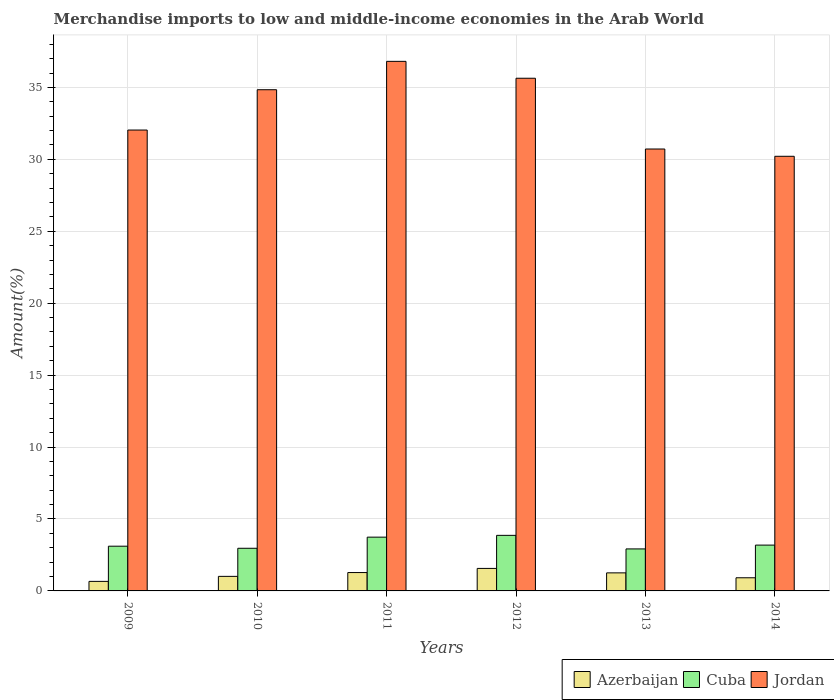How many different coloured bars are there?
Provide a succinct answer. 3. Are the number of bars per tick equal to the number of legend labels?
Your answer should be very brief. Yes. Are the number of bars on each tick of the X-axis equal?
Your response must be concise. Yes. How many bars are there on the 3rd tick from the left?
Provide a short and direct response. 3. In how many cases, is the number of bars for a given year not equal to the number of legend labels?
Make the answer very short. 0. What is the percentage of amount earned from merchandise imports in Jordan in 2011?
Make the answer very short. 36.81. Across all years, what is the maximum percentage of amount earned from merchandise imports in Jordan?
Ensure brevity in your answer.  36.81. Across all years, what is the minimum percentage of amount earned from merchandise imports in Azerbaijan?
Your answer should be compact. 0.66. In which year was the percentage of amount earned from merchandise imports in Azerbaijan minimum?
Make the answer very short. 2009. What is the total percentage of amount earned from merchandise imports in Cuba in the graph?
Your answer should be very brief. 19.78. What is the difference between the percentage of amount earned from merchandise imports in Jordan in 2010 and that in 2014?
Provide a succinct answer. 4.63. What is the difference between the percentage of amount earned from merchandise imports in Jordan in 2010 and the percentage of amount earned from merchandise imports in Azerbaijan in 2014?
Give a very brief answer. 33.93. What is the average percentage of amount earned from merchandise imports in Cuba per year?
Keep it short and to the point. 3.3. In the year 2014, what is the difference between the percentage of amount earned from merchandise imports in Jordan and percentage of amount earned from merchandise imports in Azerbaijan?
Offer a terse response. 29.3. In how many years, is the percentage of amount earned from merchandise imports in Azerbaijan greater than 5 %?
Offer a terse response. 0. What is the ratio of the percentage of amount earned from merchandise imports in Cuba in 2012 to that in 2014?
Give a very brief answer. 1.21. Is the difference between the percentage of amount earned from merchandise imports in Jordan in 2012 and 2013 greater than the difference between the percentage of amount earned from merchandise imports in Azerbaijan in 2012 and 2013?
Offer a terse response. Yes. What is the difference between the highest and the second highest percentage of amount earned from merchandise imports in Azerbaijan?
Make the answer very short. 0.29. What is the difference between the highest and the lowest percentage of amount earned from merchandise imports in Jordan?
Ensure brevity in your answer.  6.6. In how many years, is the percentage of amount earned from merchandise imports in Jordan greater than the average percentage of amount earned from merchandise imports in Jordan taken over all years?
Your answer should be very brief. 3. What does the 2nd bar from the left in 2010 represents?
Your response must be concise. Cuba. What does the 2nd bar from the right in 2012 represents?
Your response must be concise. Cuba. How many bars are there?
Ensure brevity in your answer.  18. How many years are there in the graph?
Offer a very short reply. 6. Are the values on the major ticks of Y-axis written in scientific E-notation?
Offer a terse response. No. Does the graph contain grids?
Ensure brevity in your answer.  Yes. Where does the legend appear in the graph?
Keep it short and to the point. Bottom right. How many legend labels are there?
Ensure brevity in your answer.  3. How are the legend labels stacked?
Your response must be concise. Horizontal. What is the title of the graph?
Your answer should be very brief. Merchandise imports to low and middle-income economies in the Arab World. What is the label or title of the X-axis?
Offer a very short reply. Years. What is the label or title of the Y-axis?
Your response must be concise. Amount(%). What is the Amount(%) of Azerbaijan in 2009?
Keep it short and to the point. 0.66. What is the Amount(%) in Cuba in 2009?
Offer a very short reply. 3.11. What is the Amount(%) in Jordan in 2009?
Keep it short and to the point. 32.04. What is the Amount(%) of Azerbaijan in 2010?
Your answer should be compact. 1.01. What is the Amount(%) in Cuba in 2010?
Make the answer very short. 2.96. What is the Amount(%) of Jordan in 2010?
Your answer should be very brief. 34.84. What is the Amount(%) in Azerbaijan in 2011?
Ensure brevity in your answer.  1.28. What is the Amount(%) in Cuba in 2011?
Keep it short and to the point. 3.74. What is the Amount(%) in Jordan in 2011?
Provide a succinct answer. 36.81. What is the Amount(%) in Azerbaijan in 2012?
Make the answer very short. 1.57. What is the Amount(%) of Cuba in 2012?
Make the answer very short. 3.86. What is the Amount(%) in Jordan in 2012?
Your response must be concise. 35.64. What is the Amount(%) of Azerbaijan in 2013?
Keep it short and to the point. 1.25. What is the Amount(%) of Cuba in 2013?
Provide a short and direct response. 2.92. What is the Amount(%) in Jordan in 2013?
Give a very brief answer. 30.72. What is the Amount(%) of Azerbaijan in 2014?
Ensure brevity in your answer.  0.91. What is the Amount(%) in Cuba in 2014?
Offer a terse response. 3.19. What is the Amount(%) of Jordan in 2014?
Provide a short and direct response. 30.21. Across all years, what is the maximum Amount(%) in Azerbaijan?
Provide a succinct answer. 1.57. Across all years, what is the maximum Amount(%) of Cuba?
Keep it short and to the point. 3.86. Across all years, what is the maximum Amount(%) of Jordan?
Offer a very short reply. 36.81. Across all years, what is the minimum Amount(%) in Azerbaijan?
Make the answer very short. 0.66. Across all years, what is the minimum Amount(%) in Cuba?
Your answer should be very brief. 2.92. Across all years, what is the minimum Amount(%) of Jordan?
Make the answer very short. 30.21. What is the total Amount(%) in Azerbaijan in the graph?
Make the answer very short. 6.68. What is the total Amount(%) in Cuba in the graph?
Provide a short and direct response. 19.78. What is the total Amount(%) of Jordan in the graph?
Provide a short and direct response. 200.26. What is the difference between the Amount(%) in Azerbaijan in 2009 and that in 2010?
Offer a terse response. -0.35. What is the difference between the Amount(%) in Cuba in 2009 and that in 2010?
Make the answer very short. 0.14. What is the difference between the Amount(%) of Jordan in 2009 and that in 2010?
Give a very brief answer. -2.8. What is the difference between the Amount(%) of Azerbaijan in 2009 and that in 2011?
Your answer should be compact. -0.61. What is the difference between the Amount(%) in Cuba in 2009 and that in 2011?
Offer a terse response. -0.63. What is the difference between the Amount(%) of Jordan in 2009 and that in 2011?
Make the answer very short. -4.77. What is the difference between the Amount(%) of Azerbaijan in 2009 and that in 2012?
Your answer should be compact. -0.9. What is the difference between the Amount(%) of Cuba in 2009 and that in 2012?
Your response must be concise. -0.75. What is the difference between the Amount(%) of Jordan in 2009 and that in 2012?
Provide a succinct answer. -3.6. What is the difference between the Amount(%) in Azerbaijan in 2009 and that in 2013?
Your answer should be compact. -0.59. What is the difference between the Amount(%) in Cuba in 2009 and that in 2013?
Provide a short and direct response. 0.19. What is the difference between the Amount(%) of Jordan in 2009 and that in 2013?
Offer a terse response. 1.32. What is the difference between the Amount(%) in Azerbaijan in 2009 and that in 2014?
Keep it short and to the point. -0.25. What is the difference between the Amount(%) in Cuba in 2009 and that in 2014?
Your response must be concise. -0.08. What is the difference between the Amount(%) in Jordan in 2009 and that in 2014?
Make the answer very short. 1.82. What is the difference between the Amount(%) in Azerbaijan in 2010 and that in 2011?
Ensure brevity in your answer.  -0.26. What is the difference between the Amount(%) of Cuba in 2010 and that in 2011?
Ensure brevity in your answer.  -0.77. What is the difference between the Amount(%) in Jordan in 2010 and that in 2011?
Keep it short and to the point. -1.97. What is the difference between the Amount(%) of Azerbaijan in 2010 and that in 2012?
Your answer should be compact. -0.55. What is the difference between the Amount(%) in Cuba in 2010 and that in 2012?
Offer a terse response. -0.9. What is the difference between the Amount(%) of Jordan in 2010 and that in 2012?
Your answer should be very brief. -0.8. What is the difference between the Amount(%) of Azerbaijan in 2010 and that in 2013?
Provide a short and direct response. -0.24. What is the difference between the Amount(%) of Cuba in 2010 and that in 2013?
Ensure brevity in your answer.  0.05. What is the difference between the Amount(%) of Jordan in 2010 and that in 2013?
Give a very brief answer. 4.12. What is the difference between the Amount(%) of Azerbaijan in 2010 and that in 2014?
Your answer should be compact. 0.1. What is the difference between the Amount(%) of Cuba in 2010 and that in 2014?
Give a very brief answer. -0.22. What is the difference between the Amount(%) in Jordan in 2010 and that in 2014?
Provide a succinct answer. 4.63. What is the difference between the Amount(%) in Azerbaijan in 2011 and that in 2012?
Keep it short and to the point. -0.29. What is the difference between the Amount(%) in Cuba in 2011 and that in 2012?
Your answer should be compact. -0.12. What is the difference between the Amount(%) of Jordan in 2011 and that in 2012?
Your answer should be compact. 1.17. What is the difference between the Amount(%) in Azerbaijan in 2011 and that in 2013?
Ensure brevity in your answer.  0.02. What is the difference between the Amount(%) of Cuba in 2011 and that in 2013?
Give a very brief answer. 0.82. What is the difference between the Amount(%) in Jordan in 2011 and that in 2013?
Offer a very short reply. 6.09. What is the difference between the Amount(%) of Azerbaijan in 2011 and that in 2014?
Offer a terse response. 0.36. What is the difference between the Amount(%) of Cuba in 2011 and that in 2014?
Ensure brevity in your answer.  0.55. What is the difference between the Amount(%) in Jordan in 2011 and that in 2014?
Give a very brief answer. 6.6. What is the difference between the Amount(%) in Azerbaijan in 2012 and that in 2013?
Offer a terse response. 0.31. What is the difference between the Amount(%) in Cuba in 2012 and that in 2013?
Make the answer very short. 0.94. What is the difference between the Amount(%) of Jordan in 2012 and that in 2013?
Ensure brevity in your answer.  4.92. What is the difference between the Amount(%) in Azerbaijan in 2012 and that in 2014?
Ensure brevity in your answer.  0.65. What is the difference between the Amount(%) in Cuba in 2012 and that in 2014?
Keep it short and to the point. 0.68. What is the difference between the Amount(%) in Jordan in 2012 and that in 2014?
Provide a succinct answer. 5.43. What is the difference between the Amount(%) in Azerbaijan in 2013 and that in 2014?
Provide a short and direct response. 0.34. What is the difference between the Amount(%) of Cuba in 2013 and that in 2014?
Your answer should be compact. -0.27. What is the difference between the Amount(%) in Jordan in 2013 and that in 2014?
Keep it short and to the point. 0.51. What is the difference between the Amount(%) of Azerbaijan in 2009 and the Amount(%) of Cuba in 2010?
Offer a very short reply. -2.3. What is the difference between the Amount(%) of Azerbaijan in 2009 and the Amount(%) of Jordan in 2010?
Give a very brief answer. -34.18. What is the difference between the Amount(%) of Cuba in 2009 and the Amount(%) of Jordan in 2010?
Ensure brevity in your answer.  -31.73. What is the difference between the Amount(%) of Azerbaijan in 2009 and the Amount(%) of Cuba in 2011?
Your answer should be compact. -3.08. What is the difference between the Amount(%) of Azerbaijan in 2009 and the Amount(%) of Jordan in 2011?
Your answer should be very brief. -36.15. What is the difference between the Amount(%) in Cuba in 2009 and the Amount(%) in Jordan in 2011?
Offer a very short reply. -33.7. What is the difference between the Amount(%) of Azerbaijan in 2009 and the Amount(%) of Cuba in 2012?
Offer a terse response. -3.2. What is the difference between the Amount(%) of Azerbaijan in 2009 and the Amount(%) of Jordan in 2012?
Ensure brevity in your answer.  -34.98. What is the difference between the Amount(%) in Cuba in 2009 and the Amount(%) in Jordan in 2012?
Make the answer very short. -32.53. What is the difference between the Amount(%) in Azerbaijan in 2009 and the Amount(%) in Cuba in 2013?
Ensure brevity in your answer.  -2.26. What is the difference between the Amount(%) of Azerbaijan in 2009 and the Amount(%) of Jordan in 2013?
Give a very brief answer. -30.06. What is the difference between the Amount(%) in Cuba in 2009 and the Amount(%) in Jordan in 2013?
Your response must be concise. -27.61. What is the difference between the Amount(%) in Azerbaijan in 2009 and the Amount(%) in Cuba in 2014?
Provide a succinct answer. -2.52. What is the difference between the Amount(%) of Azerbaijan in 2009 and the Amount(%) of Jordan in 2014?
Your response must be concise. -29.55. What is the difference between the Amount(%) of Cuba in 2009 and the Amount(%) of Jordan in 2014?
Offer a very short reply. -27.1. What is the difference between the Amount(%) of Azerbaijan in 2010 and the Amount(%) of Cuba in 2011?
Your answer should be very brief. -2.73. What is the difference between the Amount(%) in Azerbaijan in 2010 and the Amount(%) in Jordan in 2011?
Give a very brief answer. -35.8. What is the difference between the Amount(%) in Cuba in 2010 and the Amount(%) in Jordan in 2011?
Give a very brief answer. -33.85. What is the difference between the Amount(%) in Azerbaijan in 2010 and the Amount(%) in Cuba in 2012?
Your response must be concise. -2.85. What is the difference between the Amount(%) in Azerbaijan in 2010 and the Amount(%) in Jordan in 2012?
Make the answer very short. -34.63. What is the difference between the Amount(%) of Cuba in 2010 and the Amount(%) of Jordan in 2012?
Offer a terse response. -32.67. What is the difference between the Amount(%) of Azerbaijan in 2010 and the Amount(%) of Cuba in 2013?
Provide a succinct answer. -1.91. What is the difference between the Amount(%) in Azerbaijan in 2010 and the Amount(%) in Jordan in 2013?
Provide a succinct answer. -29.71. What is the difference between the Amount(%) in Cuba in 2010 and the Amount(%) in Jordan in 2013?
Provide a short and direct response. -27.76. What is the difference between the Amount(%) in Azerbaijan in 2010 and the Amount(%) in Cuba in 2014?
Keep it short and to the point. -2.17. What is the difference between the Amount(%) in Azerbaijan in 2010 and the Amount(%) in Jordan in 2014?
Offer a terse response. -29.2. What is the difference between the Amount(%) in Cuba in 2010 and the Amount(%) in Jordan in 2014?
Provide a succinct answer. -27.25. What is the difference between the Amount(%) of Azerbaijan in 2011 and the Amount(%) of Cuba in 2012?
Your answer should be very brief. -2.59. What is the difference between the Amount(%) in Azerbaijan in 2011 and the Amount(%) in Jordan in 2012?
Give a very brief answer. -34.36. What is the difference between the Amount(%) of Cuba in 2011 and the Amount(%) of Jordan in 2012?
Give a very brief answer. -31.9. What is the difference between the Amount(%) of Azerbaijan in 2011 and the Amount(%) of Cuba in 2013?
Offer a very short reply. -1.64. What is the difference between the Amount(%) in Azerbaijan in 2011 and the Amount(%) in Jordan in 2013?
Your answer should be very brief. -29.44. What is the difference between the Amount(%) of Cuba in 2011 and the Amount(%) of Jordan in 2013?
Provide a succinct answer. -26.98. What is the difference between the Amount(%) of Azerbaijan in 2011 and the Amount(%) of Cuba in 2014?
Offer a very short reply. -1.91. What is the difference between the Amount(%) in Azerbaijan in 2011 and the Amount(%) in Jordan in 2014?
Keep it short and to the point. -28.94. What is the difference between the Amount(%) in Cuba in 2011 and the Amount(%) in Jordan in 2014?
Your answer should be very brief. -26.47. What is the difference between the Amount(%) of Azerbaijan in 2012 and the Amount(%) of Cuba in 2013?
Provide a short and direct response. -1.35. What is the difference between the Amount(%) in Azerbaijan in 2012 and the Amount(%) in Jordan in 2013?
Ensure brevity in your answer.  -29.16. What is the difference between the Amount(%) in Cuba in 2012 and the Amount(%) in Jordan in 2013?
Provide a short and direct response. -26.86. What is the difference between the Amount(%) in Azerbaijan in 2012 and the Amount(%) in Cuba in 2014?
Provide a short and direct response. -1.62. What is the difference between the Amount(%) of Azerbaijan in 2012 and the Amount(%) of Jordan in 2014?
Your answer should be very brief. -28.65. What is the difference between the Amount(%) in Cuba in 2012 and the Amount(%) in Jordan in 2014?
Keep it short and to the point. -26.35. What is the difference between the Amount(%) in Azerbaijan in 2013 and the Amount(%) in Cuba in 2014?
Your answer should be very brief. -1.93. What is the difference between the Amount(%) of Azerbaijan in 2013 and the Amount(%) of Jordan in 2014?
Ensure brevity in your answer.  -28.96. What is the difference between the Amount(%) of Cuba in 2013 and the Amount(%) of Jordan in 2014?
Provide a short and direct response. -27.29. What is the average Amount(%) of Azerbaijan per year?
Keep it short and to the point. 1.11. What is the average Amount(%) of Cuba per year?
Offer a very short reply. 3.3. What is the average Amount(%) in Jordan per year?
Make the answer very short. 33.38. In the year 2009, what is the difference between the Amount(%) of Azerbaijan and Amount(%) of Cuba?
Offer a terse response. -2.45. In the year 2009, what is the difference between the Amount(%) in Azerbaijan and Amount(%) in Jordan?
Your answer should be compact. -31.38. In the year 2009, what is the difference between the Amount(%) in Cuba and Amount(%) in Jordan?
Provide a short and direct response. -28.93. In the year 2010, what is the difference between the Amount(%) of Azerbaijan and Amount(%) of Cuba?
Offer a very short reply. -1.95. In the year 2010, what is the difference between the Amount(%) in Azerbaijan and Amount(%) in Jordan?
Provide a short and direct response. -33.83. In the year 2010, what is the difference between the Amount(%) in Cuba and Amount(%) in Jordan?
Give a very brief answer. -31.88. In the year 2011, what is the difference between the Amount(%) of Azerbaijan and Amount(%) of Cuba?
Offer a terse response. -2.46. In the year 2011, what is the difference between the Amount(%) of Azerbaijan and Amount(%) of Jordan?
Make the answer very short. -35.54. In the year 2011, what is the difference between the Amount(%) of Cuba and Amount(%) of Jordan?
Provide a short and direct response. -33.07. In the year 2012, what is the difference between the Amount(%) in Azerbaijan and Amount(%) in Cuba?
Make the answer very short. -2.3. In the year 2012, what is the difference between the Amount(%) of Azerbaijan and Amount(%) of Jordan?
Provide a succinct answer. -34.07. In the year 2012, what is the difference between the Amount(%) in Cuba and Amount(%) in Jordan?
Provide a short and direct response. -31.78. In the year 2013, what is the difference between the Amount(%) in Azerbaijan and Amount(%) in Cuba?
Make the answer very short. -1.67. In the year 2013, what is the difference between the Amount(%) of Azerbaijan and Amount(%) of Jordan?
Give a very brief answer. -29.47. In the year 2013, what is the difference between the Amount(%) of Cuba and Amount(%) of Jordan?
Your response must be concise. -27.8. In the year 2014, what is the difference between the Amount(%) of Azerbaijan and Amount(%) of Cuba?
Give a very brief answer. -2.27. In the year 2014, what is the difference between the Amount(%) in Azerbaijan and Amount(%) in Jordan?
Provide a short and direct response. -29.3. In the year 2014, what is the difference between the Amount(%) in Cuba and Amount(%) in Jordan?
Ensure brevity in your answer.  -27.03. What is the ratio of the Amount(%) of Azerbaijan in 2009 to that in 2010?
Your answer should be very brief. 0.66. What is the ratio of the Amount(%) of Cuba in 2009 to that in 2010?
Provide a short and direct response. 1.05. What is the ratio of the Amount(%) of Jordan in 2009 to that in 2010?
Give a very brief answer. 0.92. What is the ratio of the Amount(%) in Azerbaijan in 2009 to that in 2011?
Offer a very short reply. 0.52. What is the ratio of the Amount(%) in Cuba in 2009 to that in 2011?
Provide a succinct answer. 0.83. What is the ratio of the Amount(%) of Jordan in 2009 to that in 2011?
Your answer should be compact. 0.87. What is the ratio of the Amount(%) in Azerbaijan in 2009 to that in 2012?
Your answer should be very brief. 0.42. What is the ratio of the Amount(%) of Cuba in 2009 to that in 2012?
Provide a short and direct response. 0.8. What is the ratio of the Amount(%) of Jordan in 2009 to that in 2012?
Provide a short and direct response. 0.9. What is the ratio of the Amount(%) in Azerbaijan in 2009 to that in 2013?
Your answer should be compact. 0.53. What is the ratio of the Amount(%) in Cuba in 2009 to that in 2013?
Provide a succinct answer. 1.06. What is the ratio of the Amount(%) of Jordan in 2009 to that in 2013?
Your answer should be very brief. 1.04. What is the ratio of the Amount(%) of Azerbaijan in 2009 to that in 2014?
Make the answer very short. 0.72. What is the ratio of the Amount(%) in Cuba in 2009 to that in 2014?
Offer a very short reply. 0.98. What is the ratio of the Amount(%) of Jordan in 2009 to that in 2014?
Provide a succinct answer. 1.06. What is the ratio of the Amount(%) in Azerbaijan in 2010 to that in 2011?
Keep it short and to the point. 0.79. What is the ratio of the Amount(%) of Cuba in 2010 to that in 2011?
Give a very brief answer. 0.79. What is the ratio of the Amount(%) in Jordan in 2010 to that in 2011?
Provide a short and direct response. 0.95. What is the ratio of the Amount(%) in Azerbaijan in 2010 to that in 2012?
Give a very brief answer. 0.65. What is the ratio of the Amount(%) of Cuba in 2010 to that in 2012?
Your answer should be very brief. 0.77. What is the ratio of the Amount(%) in Jordan in 2010 to that in 2012?
Make the answer very short. 0.98. What is the ratio of the Amount(%) in Azerbaijan in 2010 to that in 2013?
Your response must be concise. 0.81. What is the ratio of the Amount(%) of Cuba in 2010 to that in 2013?
Give a very brief answer. 1.02. What is the ratio of the Amount(%) in Jordan in 2010 to that in 2013?
Keep it short and to the point. 1.13. What is the ratio of the Amount(%) of Azerbaijan in 2010 to that in 2014?
Give a very brief answer. 1.11. What is the ratio of the Amount(%) of Cuba in 2010 to that in 2014?
Make the answer very short. 0.93. What is the ratio of the Amount(%) in Jordan in 2010 to that in 2014?
Make the answer very short. 1.15. What is the ratio of the Amount(%) of Azerbaijan in 2011 to that in 2012?
Provide a short and direct response. 0.82. What is the ratio of the Amount(%) of Cuba in 2011 to that in 2012?
Keep it short and to the point. 0.97. What is the ratio of the Amount(%) of Jordan in 2011 to that in 2012?
Your answer should be very brief. 1.03. What is the ratio of the Amount(%) of Azerbaijan in 2011 to that in 2013?
Provide a succinct answer. 1.02. What is the ratio of the Amount(%) of Cuba in 2011 to that in 2013?
Make the answer very short. 1.28. What is the ratio of the Amount(%) in Jordan in 2011 to that in 2013?
Your answer should be compact. 1.2. What is the ratio of the Amount(%) in Azerbaijan in 2011 to that in 2014?
Offer a terse response. 1.4. What is the ratio of the Amount(%) of Cuba in 2011 to that in 2014?
Make the answer very short. 1.17. What is the ratio of the Amount(%) in Jordan in 2011 to that in 2014?
Your answer should be very brief. 1.22. What is the ratio of the Amount(%) of Azerbaijan in 2012 to that in 2013?
Provide a short and direct response. 1.25. What is the ratio of the Amount(%) of Cuba in 2012 to that in 2013?
Provide a succinct answer. 1.32. What is the ratio of the Amount(%) of Jordan in 2012 to that in 2013?
Ensure brevity in your answer.  1.16. What is the ratio of the Amount(%) in Azerbaijan in 2012 to that in 2014?
Make the answer very short. 1.71. What is the ratio of the Amount(%) in Cuba in 2012 to that in 2014?
Your answer should be compact. 1.21. What is the ratio of the Amount(%) of Jordan in 2012 to that in 2014?
Provide a succinct answer. 1.18. What is the ratio of the Amount(%) of Azerbaijan in 2013 to that in 2014?
Keep it short and to the point. 1.37. What is the ratio of the Amount(%) in Cuba in 2013 to that in 2014?
Provide a short and direct response. 0.92. What is the ratio of the Amount(%) in Jordan in 2013 to that in 2014?
Your response must be concise. 1.02. What is the difference between the highest and the second highest Amount(%) in Azerbaijan?
Provide a short and direct response. 0.29. What is the difference between the highest and the second highest Amount(%) of Cuba?
Offer a very short reply. 0.12. What is the difference between the highest and the second highest Amount(%) of Jordan?
Offer a very short reply. 1.17. What is the difference between the highest and the lowest Amount(%) of Azerbaijan?
Make the answer very short. 0.9. What is the difference between the highest and the lowest Amount(%) of Cuba?
Provide a succinct answer. 0.94. What is the difference between the highest and the lowest Amount(%) of Jordan?
Ensure brevity in your answer.  6.6. 